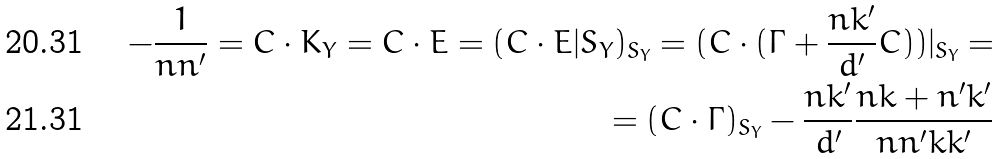<formula> <loc_0><loc_0><loc_500><loc_500>- \frac { 1 } { n n ^ { \prime } } = C \cdot K _ { Y } = C \cdot E = ( C \cdot E | { S _ { Y } } ) _ { S _ { Y } } = ( C \cdot ( \Gamma + \frac { n k ^ { \prime } } { d ^ { \prime } } C ) ) | _ { S _ { Y } } = \\ = ( C \cdot \Gamma ) _ { S _ { Y } } - \frac { n k ^ { \prime } } { d ^ { \prime } } \frac { n k + n ^ { \prime } k ^ { \prime } } { n n ^ { \prime } k k ^ { \prime } }</formula> 